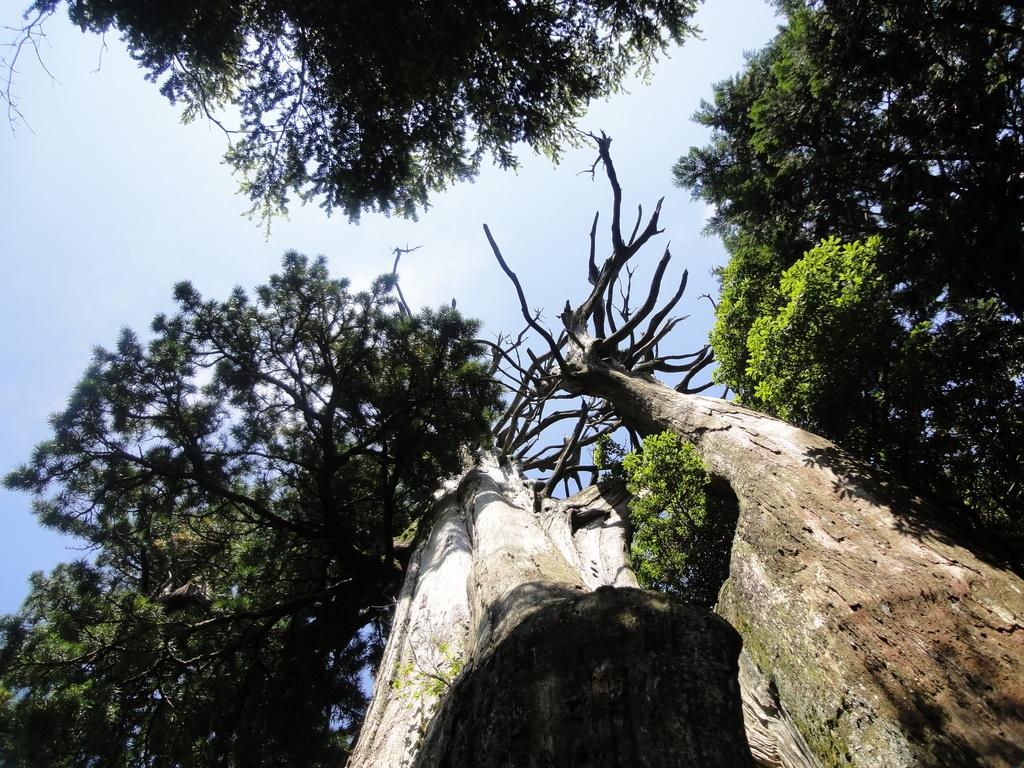What type of natural elements can be seen in the image? There are trees in the image. What is the condition of the sky in the image? The sky is cloudy in the image. What type of mailbox can be seen in the image? There is no mailbox present in the image. What is the level of friction between the trees in the image? The level of friction between the trees cannot be determined from the image. What can be heard in the image? The image is silent, so nothing can be heard. 